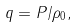<formula> <loc_0><loc_0><loc_500><loc_500>q = P / \rho _ { 0 } ,</formula> 